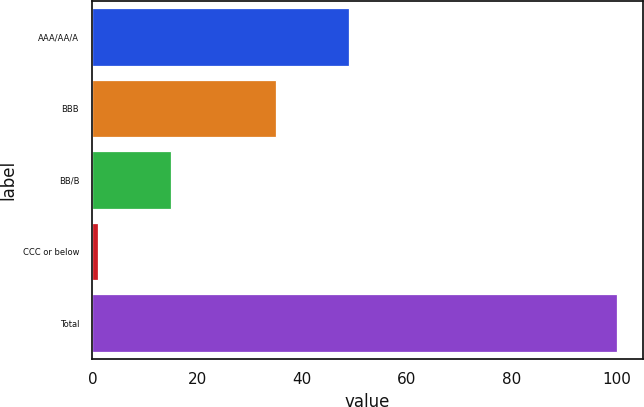Convert chart to OTSL. <chart><loc_0><loc_0><loc_500><loc_500><bar_chart><fcel>AAA/AA/A<fcel>BBB<fcel>BB/B<fcel>CCC or below<fcel>Total<nl><fcel>49<fcel>35<fcel>15<fcel>1<fcel>100<nl></chart> 